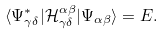<formula> <loc_0><loc_0><loc_500><loc_500>\langle \Psi ^ { * } _ { \gamma \delta } | \mathcal { H } _ { \gamma \delta } ^ { \alpha \beta } | \Psi _ { \alpha \beta } \rangle = E .</formula> 